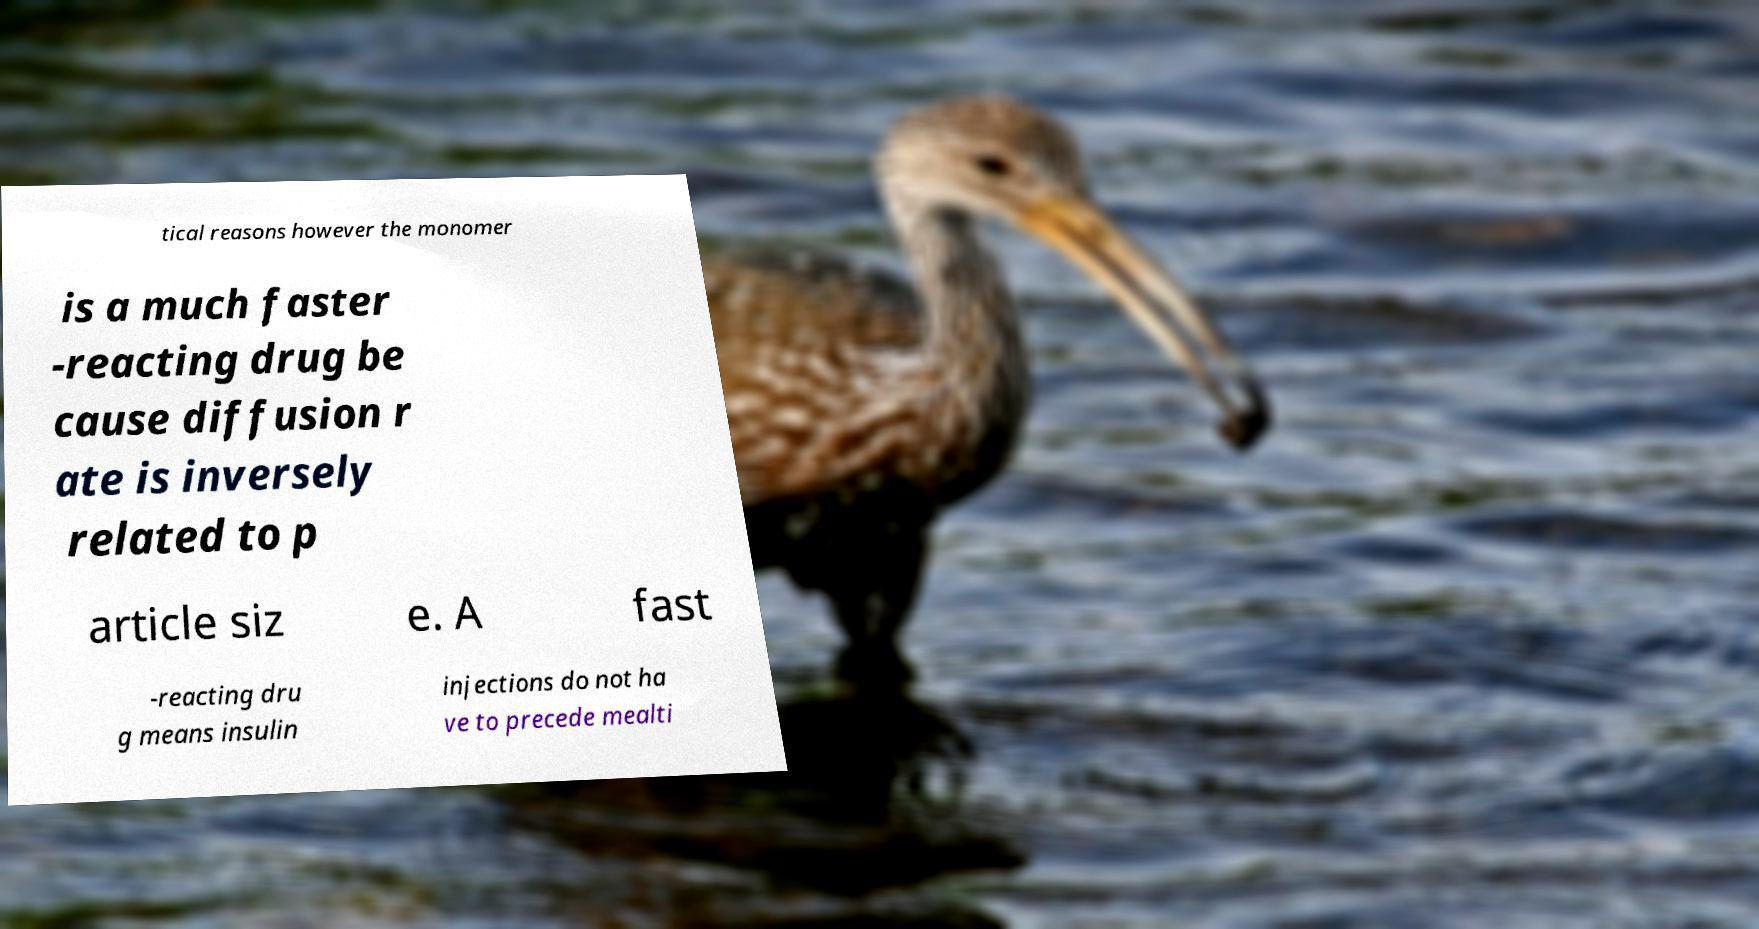Can you read and provide the text displayed in the image?This photo seems to have some interesting text. Can you extract and type it out for me? tical reasons however the monomer is a much faster -reacting drug be cause diffusion r ate is inversely related to p article siz e. A fast -reacting dru g means insulin injections do not ha ve to precede mealti 